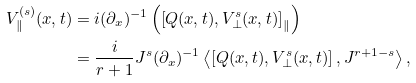Convert formula to latex. <formula><loc_0><loc_0><loc_500><loc_500>V ^ { ( s ) } _ { \| } ( x , t ) & = i ( \partial _ { x } ) ^ { - 1 } \left ( \left [ Q ( x , t ) , V ^ { s } _ { \bot } ( x , t ) \right ] _ { \| } \right ) \\ & = \frac { i } { r + 1 } J ^ { s } ( \partial _ { x } ) ^ { - 1 } \left < \left [ Q ( x , t ) , V ^ { s } _ { \bot } ( x , t ) \right ] , J ^ { r + 1 - s } \right > ,</formula> 